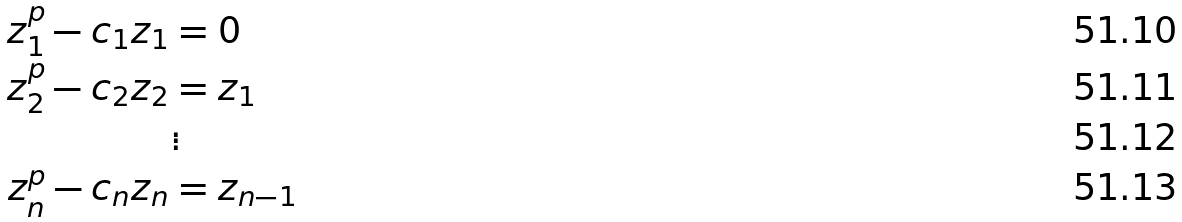Convert formula to latex. <formula><loc_0><loc_0><loc_500><loc_500>z _ { 1 } ^ { p } - c _ { 1 } z _ { 1 } & = 0 \\ z _ { 2 } ^ { p } - c _ { 2 } z _ { 2 } & = z _ { 1 } \\ & \vdots \\ z _ { n } ^ { p } - c _ { n } z _ { n } & = z _ { n - 1 }</formula> 